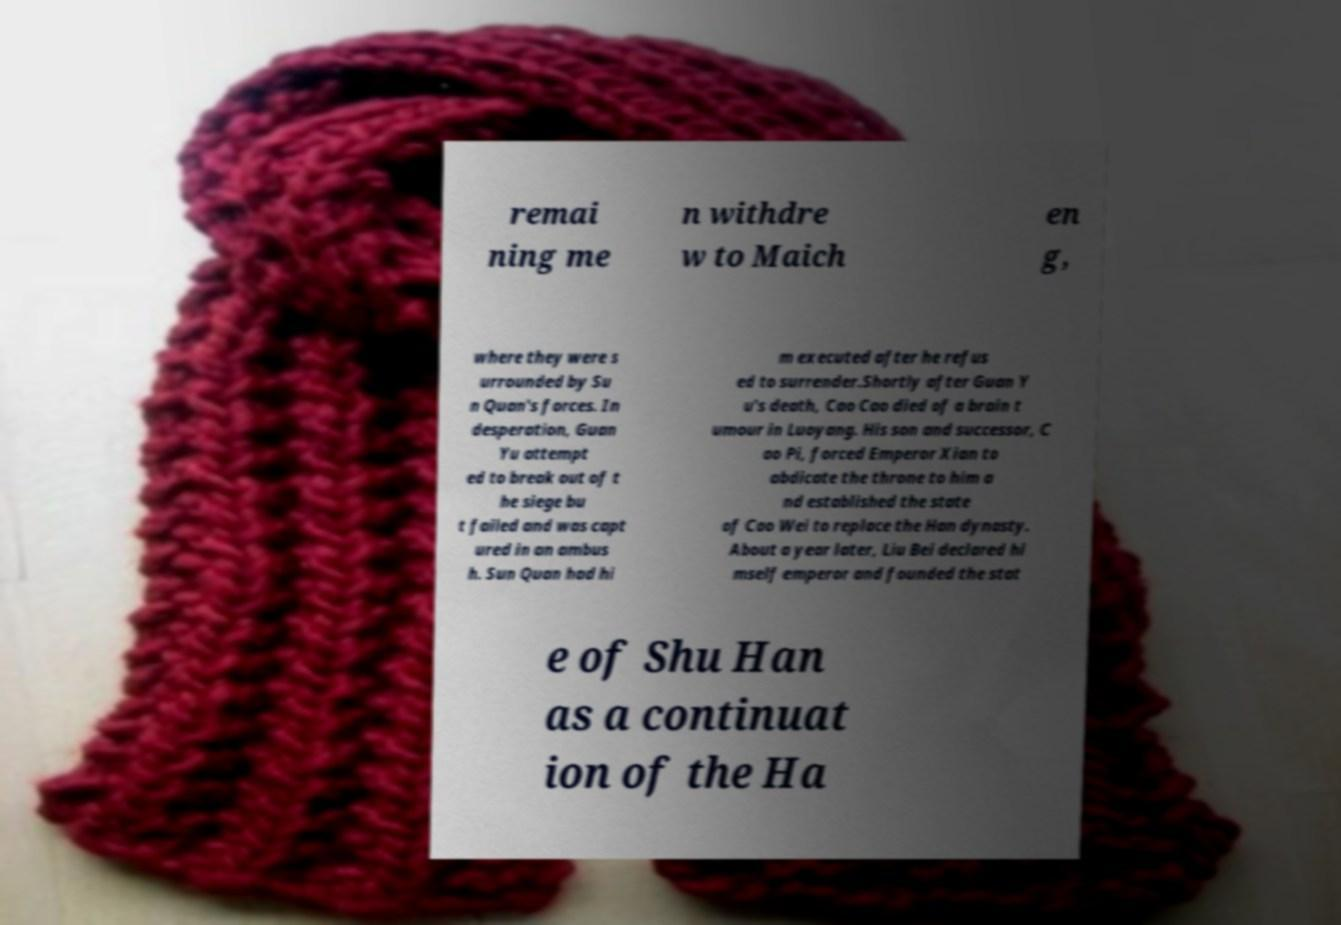Could you assist in decoding the text presented in this image and type it out clearly? remai ning me n withdre w to Maich en g, where they were s urrounded by Su n Quan's forces. In desperation, Guan Yu attempt ed to break out of t he siege bu t failed and was capt ured in an ambus h. Sun Quan had hi m executed after he refus ed to surrender.Shortly after Guan Y u's death, Cao Cao died of a brain t umour in Luoyang. His son and successor, C ao Pi, forced Emperor Xian to abdicate the throne to him a nd established the state of Cao Wei to replace the Han dynasty. About a year later, Liu Bei declared hi mself emperor and founded the stat e of Shu Han as a continuat ion of the Ha 